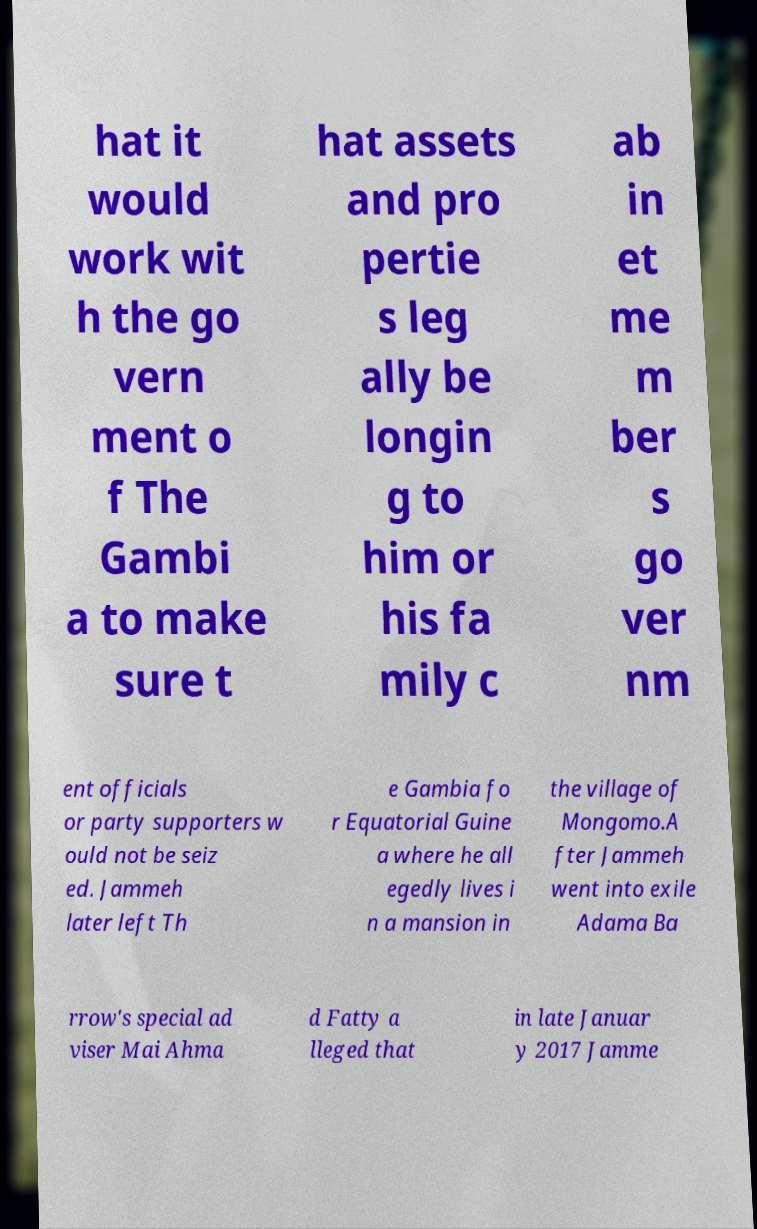Can you read and provide the text displayed in the image?This photo seems to have some interesting text. Can you extract and type it out for me? hat it would work wit h the go vern ment o f The Gambi a to make sure t hat assets and pro pertie s leg ally be longin g to him or his fa mily c ab in et me m ber s go ver nm ent officials or party supporters w ould not be seiz ed. Jammeh later left Th e Gambia fo r Equatorial Guine a where he all egedly lives i n a mansion in the village of Mongomo.A fter Jammeh went into exile Adama Ba rrow's special ad viser Mai Ahma d Fatty a lleged that in late Januar y 2017 Jamme 